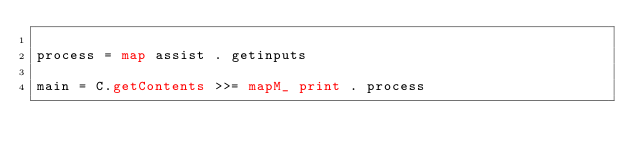<code> <loc_0><loc_0><loc_500><loc_500><_Haskell_>
process = map assist . getinputs

main = C.getContents >>= mapM_ print . process

</code> 